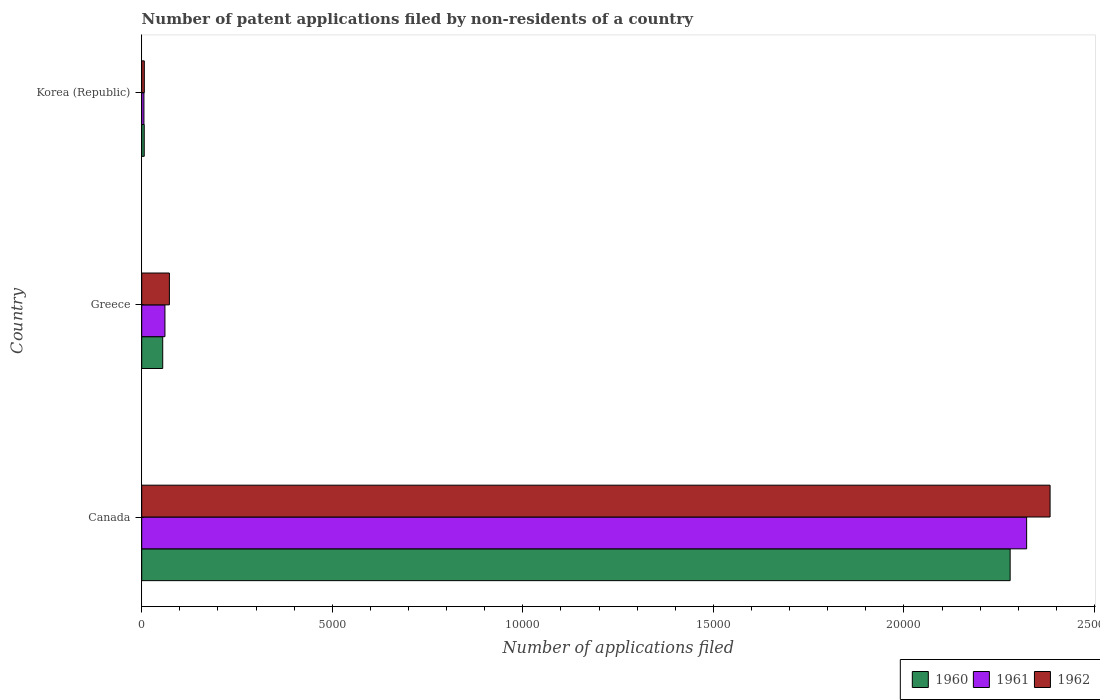How many different coloured bars are there?
Provide a short and direct response. 3. How many groups of bars are there?
Your answer should be compact. 3. Across all countries, what is the maximum number of applications filed in 1961?
Keep it short and to the point. 2.32e+04. Across all countries, what is the minimum number of applications filed in 1961?
Keep it short and to the point. 58. In which country was the number of applications filed in 1961 maximum?
Ensure brevity in your answer.  Canada. What is the total number of applications filed in 1962 in the graph?
Provide a short and direct response. 2.46e+04. What is the difference between the number of applications filed in 1961 in Canada and that in Greece?
Keep it short and to the point. 2.26e+04. What is the difference between the number of applications filed in 1962 in Greece and the number of applications filed in 1961 in Korea (Republic)?
Make the answer very short. 668. What is the average number of applications filed in 1961 per country?
Your answer should be compact. 7962. What is the difference between the number of applications filed in 1962 and number of applications filed in 1960 in Canada?
Make the answer very short. 1048. In how many countries, is the number of applications filed in 1960 greater than 16000 ?
Offer a very short reply. 1. What is the ratio of the number of applications filed in 1962 in Canada to that in Korea (Republic)?
Your answer should be very brief. 350.5. Is the difference between the number of applications filed in 1962 in Canada and Greece greater than the difference between the number of applications filed in 1960 in Canada and Greece?
Your response must be concise. Yes. What is the difference between the highest and the second highest number of applications filed in 1961?
Your answer should be very brief. 2.26e+04. What is the difference between the highest and the lowest number of applications filed in 1961?
Provide a short and direct response. 2.32e+04. In how many countries, is the number of applications filed in 1961 greater than the average number of applications filed in 1961 taken over all countries?
Ensure brevity in your answer.  1. Is the sum of the number of applications filed in 1961 in Canada and Greece greater than the maximum number of applications filed in 1962 across all countries?
Ensure brevity in your answer.  No. What does the 1st bar from the bottom in Korea (Republic) represents?
Make the answer very short. 1960. Is it the case that in every country, the sum of the number of applications filed in 1962 and number of applications filed in 1961 is greater than the number of applications filed in 1960?
Your answer should be compact. Yes. How many countries are there in the graph?
Offer a terse response. 3. Does the graph contain any zero values?
Offer a very short reply. No. Does the graph contain grids?
Offer a terse response. No. How many legend labels are there?
Keep it short and to the point. 3. How are the legend labels stacked?
Your response must be concise. Horizontal. What is the title of the graph?
Provide a succinct answer. Number of patent applications filed by non-residents of a country. Does "1966" appear as one of the legend labels in the graph?
Your answer should be compact. No. What is the label or title of the X-axis?
Provide a succinct answer. Number of applications filed. What is the Number of applications filed of 1960 in Canada?
Ensure brevity in your answer.  2.28e+04. What is the Number of applications filed in 1961 in Canada?
Ensure brevity in your answer.  2.32e+04. What is the Number of applications filed in 1962 in Canada?
Your answer should be compact. 2.38e+04. What is the Number of applications filed in 1960 in Greece?
Your answer should be compact. 551. What is the Number of applications filed of 1961 in Greece?
Offer a very short reply. 609. What is the Number of applications filed of 1962 in Greece?
Give a very brief answer. 726. What is the Number of applications filed in 1960 in Korea (Republic)?
Give a very brief answer. 66. What is the Number of applications filed in 1961 in Korea (Republic)?
Your response must be concise. 58. Across all countries, what is the maximum Number of applications filed in 1960?
Make the answer very short. 2.28e+04. Across all countries, what is the maximum Number of applications filed in 1961?
Ensure brevity in your answer.  2.32e+04. Across all countries, what is the maximum Number of applications filed in 1962?
Provide a short and direct response. 2.38e+04. Across all countries, what is the minimum Number of applications filed in 1962?
Provide a short and direct response. 68. What is the total Number of applications filed of 1960 in the graph?
Offer a very short reply. 2.34e+04. What is the total Number of applications filed in 1961 in the graph?
Ensure brevity in your answer.  2.39e+04. What is the total Number of applications filed in 1962 in the graph?
Provide a succinct answer. 2.46e+04. What is the difference between the Number of applications filed of 1960 in Canada and that in Greece?
Your answer should be very brief. 2.22e+04. What is the difference between the Number of applications filed in 1961 in Canada and that in Greece?
Offer a very short reply. 2.26e+04. What is the difference between the Number of applications filed in 1962 in Canada and that in Greece?
Your answer should be very brief. 2.31e+04. What is the difference between the Number of applications filed of 1960 in Canada and that in Korea (Republic)?
Offer a terse response. 2.27e+04. What is the difference between the Number of applications filed in 1961 in Canada and that in Korea (Republic)?
Offer a very short reply. 2.32e+04. What is the difference between the Number of applications filed of 1962 in Canada and that in Korea (Republic)?
Provide a succinct answer. 2.38e+04. What is the difference between the Number of applications filed of 1960 in Greece and that in Korea (Republic)?
Offer a very short reply. 485. What is the difference between the Number of applications filed in 1961 in Greece and that in Korea (Republic)?
Give a very brief answer. 551. What is the difference between the Number of applications filed of 1962 in Greece and that in Korea (Republic)?
Offer a very short reply. 658. What is the difference between the Number of applications filed of 1960 in Canada and the Number of applications filed of 1961 in Greece?
Your response must be concise. 2.22e+04. What is the difference between the Number of applications filed of 1960 in Canada and the Number of applications filed of 1962 in Greece?
Provide a short and direct response. 2.21e+04. What is the difference between the Number of applications filed of 1961 in Canada and the Number of applications filed of 1962 in Greece?
Offer a terse response. 2.25e+04. What is the difference between the Number of applications filed in 1960 in Canada and the Number of applications filed in 1961 in Korea (Republic)?
Your response must be concise. 2.27e+04. What is the difference between the Number of applications filed in 1960 in Canada and the Number of applications filed in 1962 in Korea (Republic)?
Your answer should be very brief. 2.27e+04. What is the difference between the Number of applications filed of 1961 in Canada and the Number of applications filed of 1962 in Korea (Republic)?
Your answer should be compact. 2.32e+04. What is the difference between the Number of applications filed in 1960 in Greece and the Number of applications filed in 1961 in Korea (Republic)?
Give a very brief answer. 493. What is the difference between the Number of applications filed of 1960 in Greece and the Number of applications filed of 1962 in Korea (Republic)?
Keep it short and to the point. 483. What is the difference between the Number of applications filed of 1961 in Greece and the Number of applications filed of 1962 in Korea (Republic)?
Give a very brief answer. 541. What is the average Number of applications filed in 1960 per country?
Ensure brevity in your answer.  7801. What is the average Number of applications filed in 1961 per country?
Offer a very short reply. 7962. What is the average Number of applications filed of 1962 per country?
Give a very brief answer. 8209.33. What is the difference between the Number of applications filed in 1960 and Number of applications filed in 1961 in Canada?
Your answer should be compact. -433. What is the difference between the Number of applications filed of 1960 and Number of applications filed of 1962 in Canada?
Your response must be concise. -1048. What is the difference between the Number of applications filed of 1961 and Number of applications filed of 1962 in Canada?
Provide a succinct answer. -615. What is the difference between the Number of applications filed of 1960 and Number of applications filed of 1961 in Greece?
Your answer should be compact. -58. What is the difference between the Number of applications filed of 1960 and Number of applications filed of 1962 in Greece?
Offer a terse response. -175. What is the difference between the Number of applications filed in 1961 and Number of applications filed in 1962 in Greece?
Offer a very short reply. -117. What is the ratio of the Number of applications filed in 1960 in Canada to that in Greece?
Make the answer very short. 41.35. What is the ratio of the Number of applications filed in 1961 in Canada to that in Greece?
Ensure brevity in your answer.  38.13. What is the ratio of the Number of applications filed in 1962 in Canada to that in Greece?
Give a very brief answer. 32.83. What is the ratio of the Number of applications filed in 1960 in Canada to that in Korea (Republic)?
Your answer should be very brief. 345.24. What is the ratio of the Number of applications filed of 1961 in Canada to that in Korea (Republic)?
Provide a short and direct response. 400.33. What is the ratio of the Number of applications filed in 1962 in Canada to that in Korea (Republic)?
Ensure brevity in your answer.  350.5. What is the ratio of the Number of applications filed of 1960 in Greece to that in Korea (Republic)?
Your response must be concise. 8.35. What is the ratio of the Number of applications filed of 1961 in Greece to that in Korea (Republic)?
Make the answer very short. 10.5. What is the ratio of the Number of applications filed in 1962 in Greece to that in Korea (Republic)?
Your answer should be compact. 10.68. What is the difference between the highest and the second highest Number of applications filed in 1960?
Offer a very short reply. 2.22e+04. What is the difference between the highest and the second highest Number of applications filed of 1961?
Ensure brevity in your answer.  2.26e+04. What is the difference between the highest and the second highest Number of applications filed in 1962?
Offer a very short reply. 2.31e+04. What is the difference between the highest and the lowest Number of applications filed in 1960?
Keep it short and to the point. 2.27e+04. What is the difference between the highest and the lowest Number of applications filed in 1961?
Offer a terse response. 2.32e+04. What is the difference between the highest and the lowest Number of applications filed in 1962?
Your answer should be compact. 2.38e+04. 